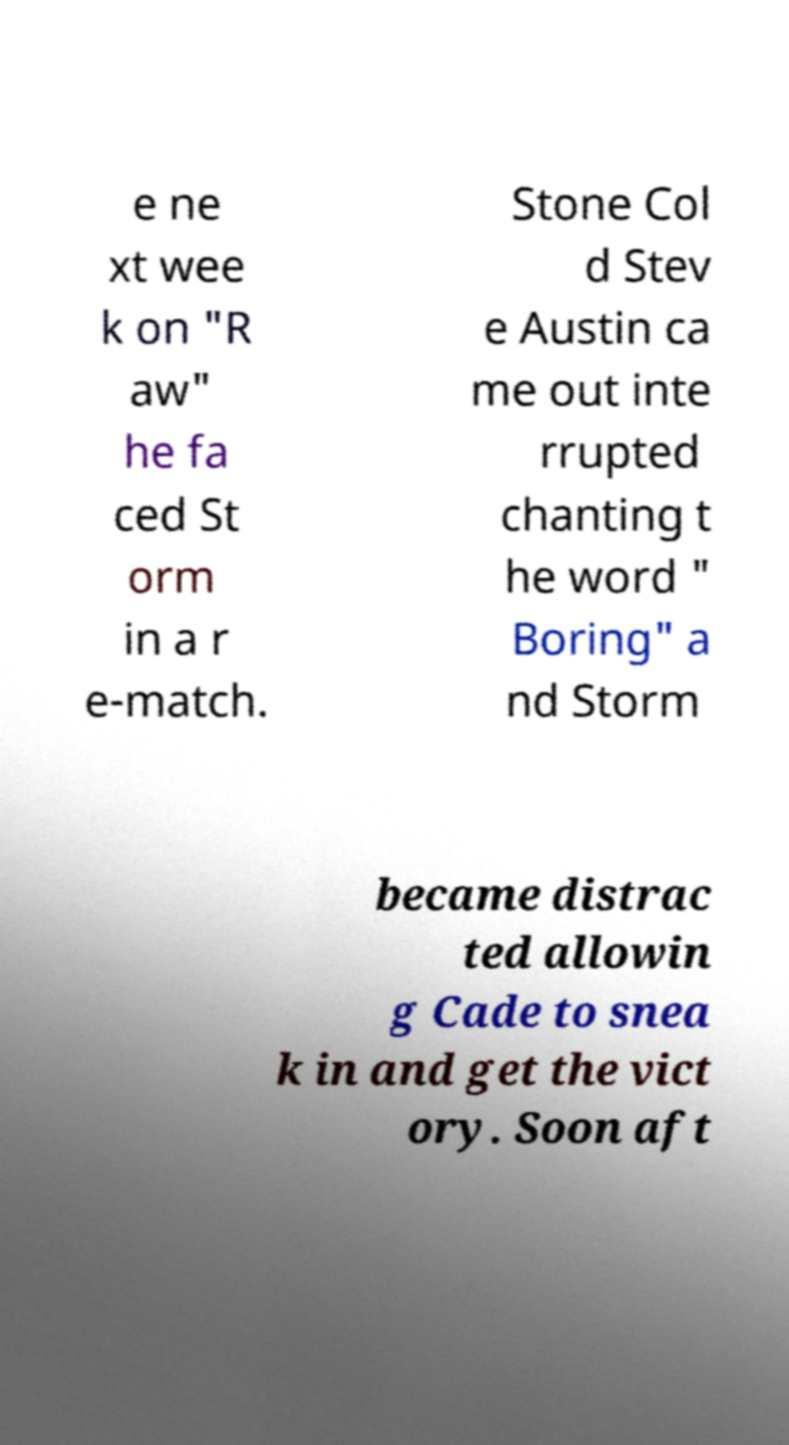Can you read and provide the text displayed in the image?This photo seems to have some interesting text. Can you extract and type it out for me? e ne xt wee k on "R aw" he fa ced St orm in a r e-match. Stone Col d Stev e Austin ca me out inte rrupted chanting t he word " Boring" a nd Storm became distrac ted allowin g Cade to snea k in and get the vict ory. Soon aft 